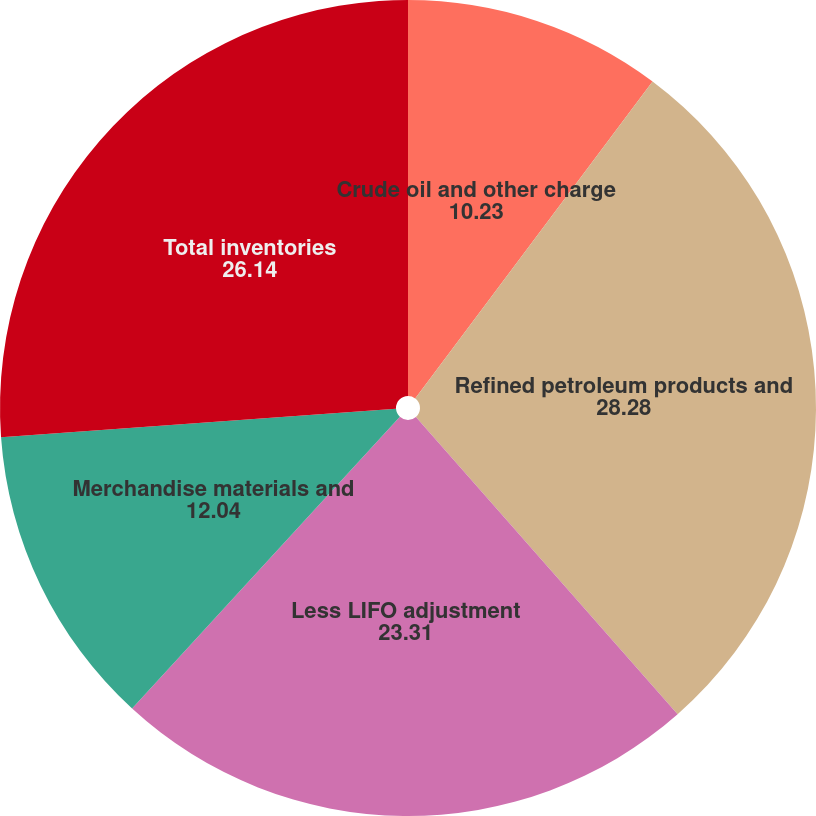Convert chart to OTSL. <chart><loc_0><loc_0><loc_500><loc_500><pie_chart><fcel>Crude oil and other charge<fcel>Refined petroleum products and<fcel>Less LIFO adjustment<fcel>Merchandise materials and<fcel>Total inventories<nl><fcel>10.23%<fcel>28.28%<fcel>23.31%<fcel>12.04%<fcel>26.14%<nl></chart> 